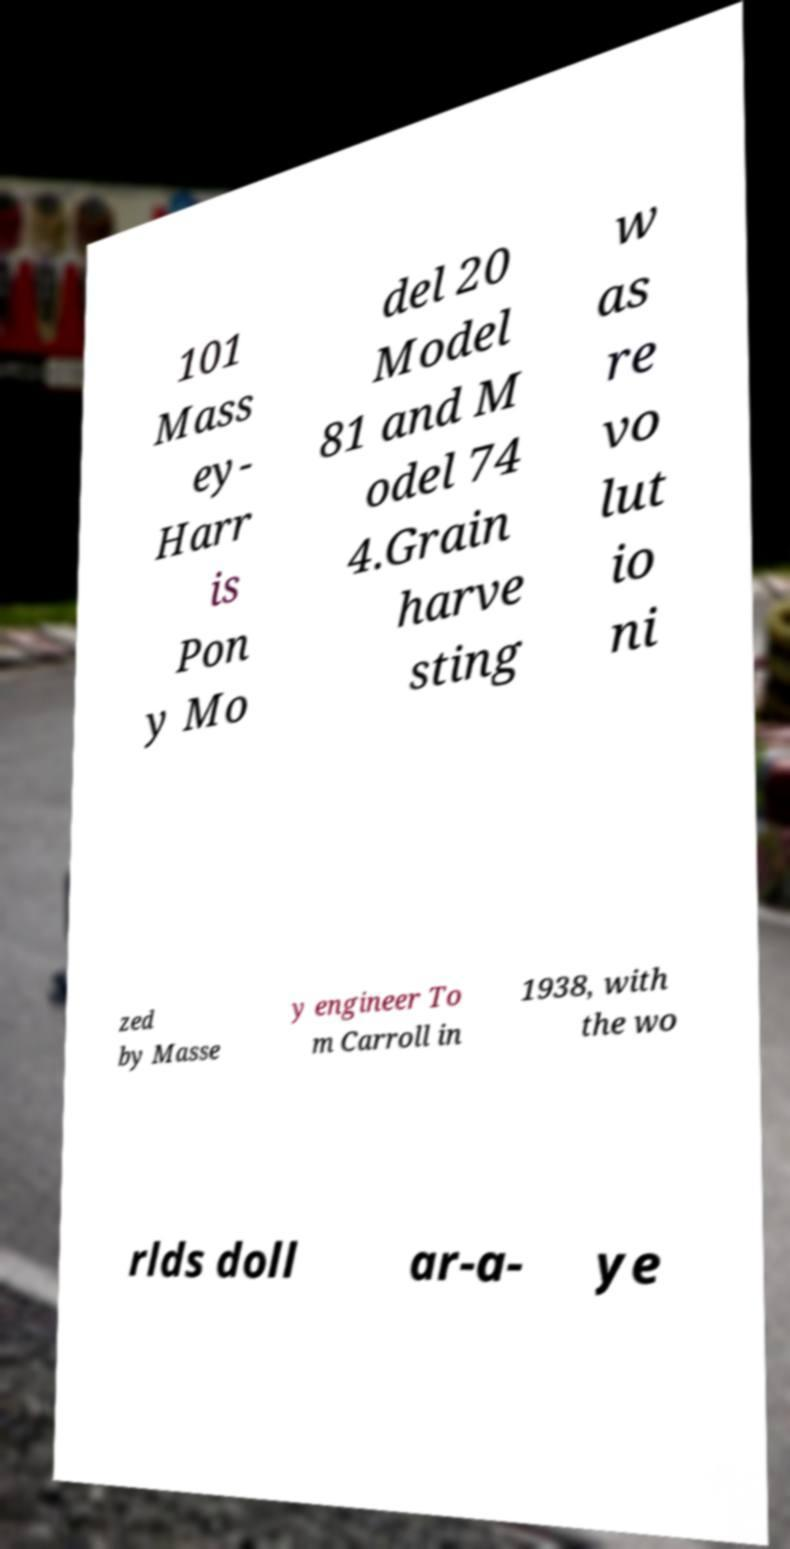Could you assist in decoding the text presented in this image and type it out clearly? 101 Mass ey- Harr is Pon y Mo del 20 Model 81 and M odel 74 4.Grain harve sting w as re vo lut io ni zed by Masse y engineer To m Carroll in 1938, with the wo rlds doll ar-a- ye 